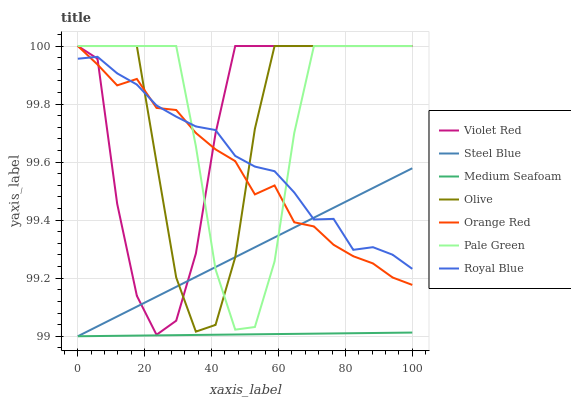Does Medium Seafoam have the minimum area under the curve?
Answer yes or no. Yes. Does Pale Green have the maximum area under the curve?
Answer yes or no. Yes. Does Steel Blue have the minimum area under the curve?
Answer yes or no. No. Does Steel Blue have the maximum area under the curve?
Answer yes or no. No. Is Steel Blue the smoothest?
Answer yes or no. Yes. Is Violet Red the roughest?
Answer yes or no. Yes. Is Medium Seafoam the smoothest?
Answer yes or no. No. Is Medium Seafoam the roughest?
Answer yes or no. No. Does Steel Blue have the lowest value?
Answer yes or no. Yes. Does Royal Blue have the lowest value?
Answer yes or no. No. Does Orange Red have the highest value?
Answer yes or no. Yes. Does Steel Blue have the highest value?
Answer yes or no. No. Is Medium Seafoam less than Olive?
Answer yes or no. Yes. Is Royal Blue greater than Medium Seafoam?
Answer yes or no. Yes. Does Pale Green intersect Violet Red?
Answer yes or no. Yes. Is Pale Green less than Violet Red?
Answer yes or no. No. Is Pale Green greater than Violet Red?
Answer yes or no. No. Does Medium Seafoam intersect Olive?
Answer yes or no. No. 